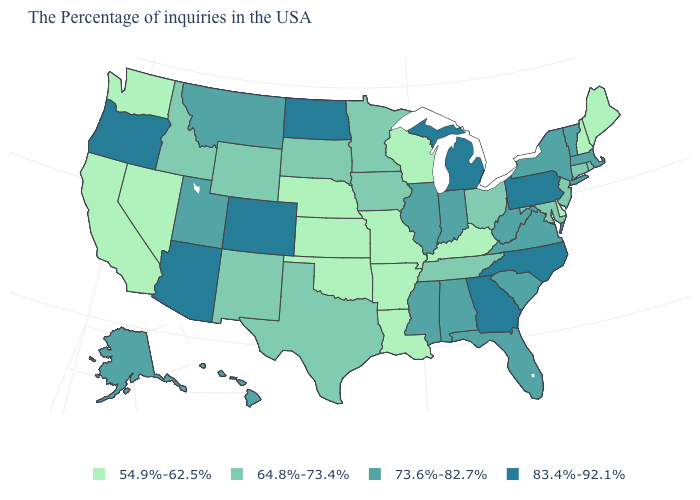Does the map have missing data?
Write a very short answer. No. Which states hav the highest value in the West?
Quick response, please. Colorado, Arizona, Oregon. Among the states that border Ohio , does Kentucky have the lowest value?
Short answer required. Yes. What is the highest value in the USA?
Short answer required. 83.4%-92.1%. What is the value of Wisconsin?
Short answer required. 54.9%-62.5%. Does the map have missing data?
Give a very brief answer. No. Does Colorado have the highest value in the USA?
Concise answer only. Yes. What is the value of Alabama?
Quick response, please. 73.6%-82.7%. Among the states that border Illinois , which have the lowest value?
Write a very short answer. Kentucky, Wisconsin, Missouri. Which states have the lowest value in the South?
Quick response, please. Delaware, Kentucky, Louisiana, Arkansas, Oklahoma. Name the states that have a value in the range 64.8%-73.4%?
Quick response, please. Rhode Island, Connecticut, New Jersey, Maryland, Ohio, Tennessee, Minnesota, Iowa, Texas, South Dakota, Wyoming, New Mexico, Idaho. Name the states that have a value in the range 54.9%-62.5%?
Concise answer only. Maine, New Hampshire, Delaware, Kentucky, Wisconsin, Louisiana, Missouri, Arkansas, Kansas, Nebraska, Oklahoma, Nevada, California, Washington. Name the states that have a value in the range 64.8%-73.4%?
Give a very brief answer. Rhode Island, Connecticut, New Jersey, Maryland, Ohio, Tennessee, Minnesota, Iowa, Texas, South Dakota, Wyoming, New Mexico, Idaho. Does Arkansas have the lowest value in the USA?
Give a very brief answer. Yes. What is the value of New York?
Write a very short answer. 73.6%-82.7%. 